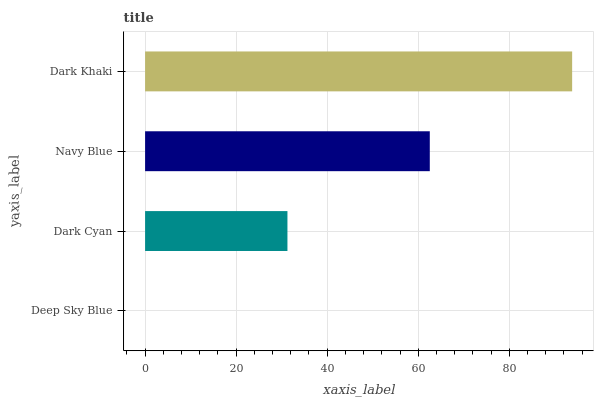Is Deep Sky Blue the minimum?
Answer yes or no. Yes. Is Dark Khaki the maximum?
Answer yes or no. Yes. Is Dark Cyan the minimum?
Answer yes or no. No. Is Dark Cyan the maximum?
Answer yes or no. No. Is Dark Cyan greater than Deep Sky Blue?
Answer yes or no. Yes. Is Deep Sky Blue less than Dark Cyan?
Answer yes or no. Yes. Is Deep Sky Blue greater than Dark Cyan?
Answer yes or no. No. Is Dark Cyan less than Deep Sky Blue?
Answer yes or no. No. Is Navy Blue the high median?
Answer yes or no. Yes. Is Dark Cyan the low median?
Answer yes or no. Yes. Is Deep Sky Blue the high median?
Answer yes or no. No. Is Deep Sky Blue the low median?
Answer yes or no. No. 